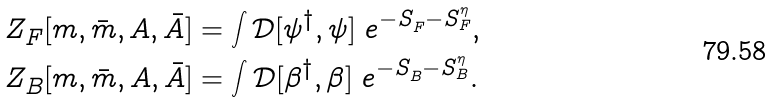<formula> <loc_0><loc_0><loc_500><loc_500>& Z ^ { \ } _ { F } [ m , \bar { m } , A , \bar { A } ] = \int \mathcal { D } [ \psi ^ { \dag } , \psi ] \ e ^ { - S ^ { \ } _ { F } - S ^ { \eta } _ { F } } , \\ & Z ^ { \ } _ { B } [ m , \bar { m } , A , \bar { A } ] = \int \mathcal { D } [ \beta ^ { \dag } , \beta ] \ e ^ { - S ^ { \ } _ { B } - S ^ { \eta } _ { B } } .</formula> 